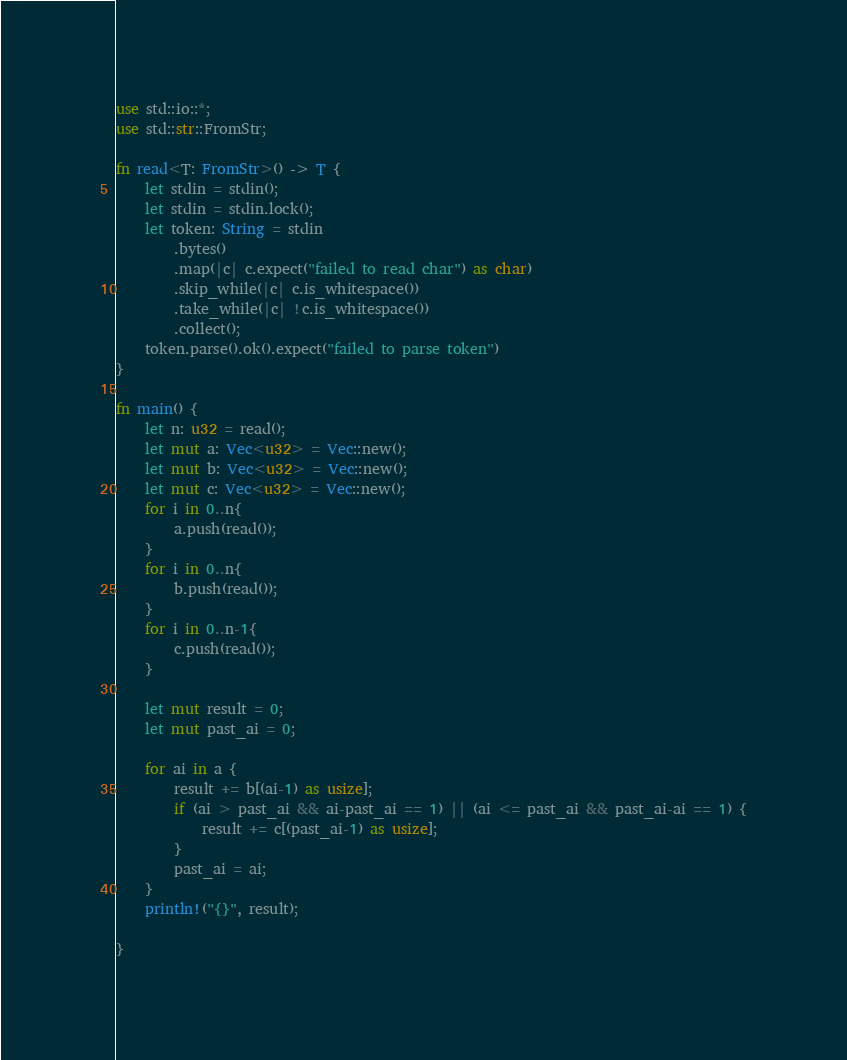Convert code to text. <code><loc_0><loc_0><loc_500><loc_500><_Rust_>use std::io::*;
use std::str::FromStr;
   
fn read<T: FromStr>() -> T {
	let stdin = stdin();
    let stdin = stdin.lock();
    let token: String = stdin
        .bytes()
        .map(|c| c.expect("failed to read char") as char)
        .skip_while(|c| c.is_whitespace())
        .take_while(|c| !c.is_whitespace())
        .collect();
    token.parse().ok().expect("failed to parse token")
}

fn main() {
	let n: u32 = read();
	let mut a: Vec<u32> = Vec::new();
	let mut b: Vec<u32> = Vec::new();
	let mut c: Vec<u32> = Vec::new();
	for i in 0..n{
		a.push(read());
	}
	for i in 0..n{
		b.push(read());
	}
	for i in 0..n-1{
		c.push(read());
	}

	let mut result = 0;
	let mut past_ai = 0;
	
	for ai in a {
		result += b[(ai-1) as usize];
		if (ai > past_ai && ai-past_ai == 1) || (ai <= past_ai && past_ai-ai == 1) {
			result += c[(past_ai-1) as usize];
		}
		past_ai = ai;
	}
	println!("{}", result);

}
</code> 